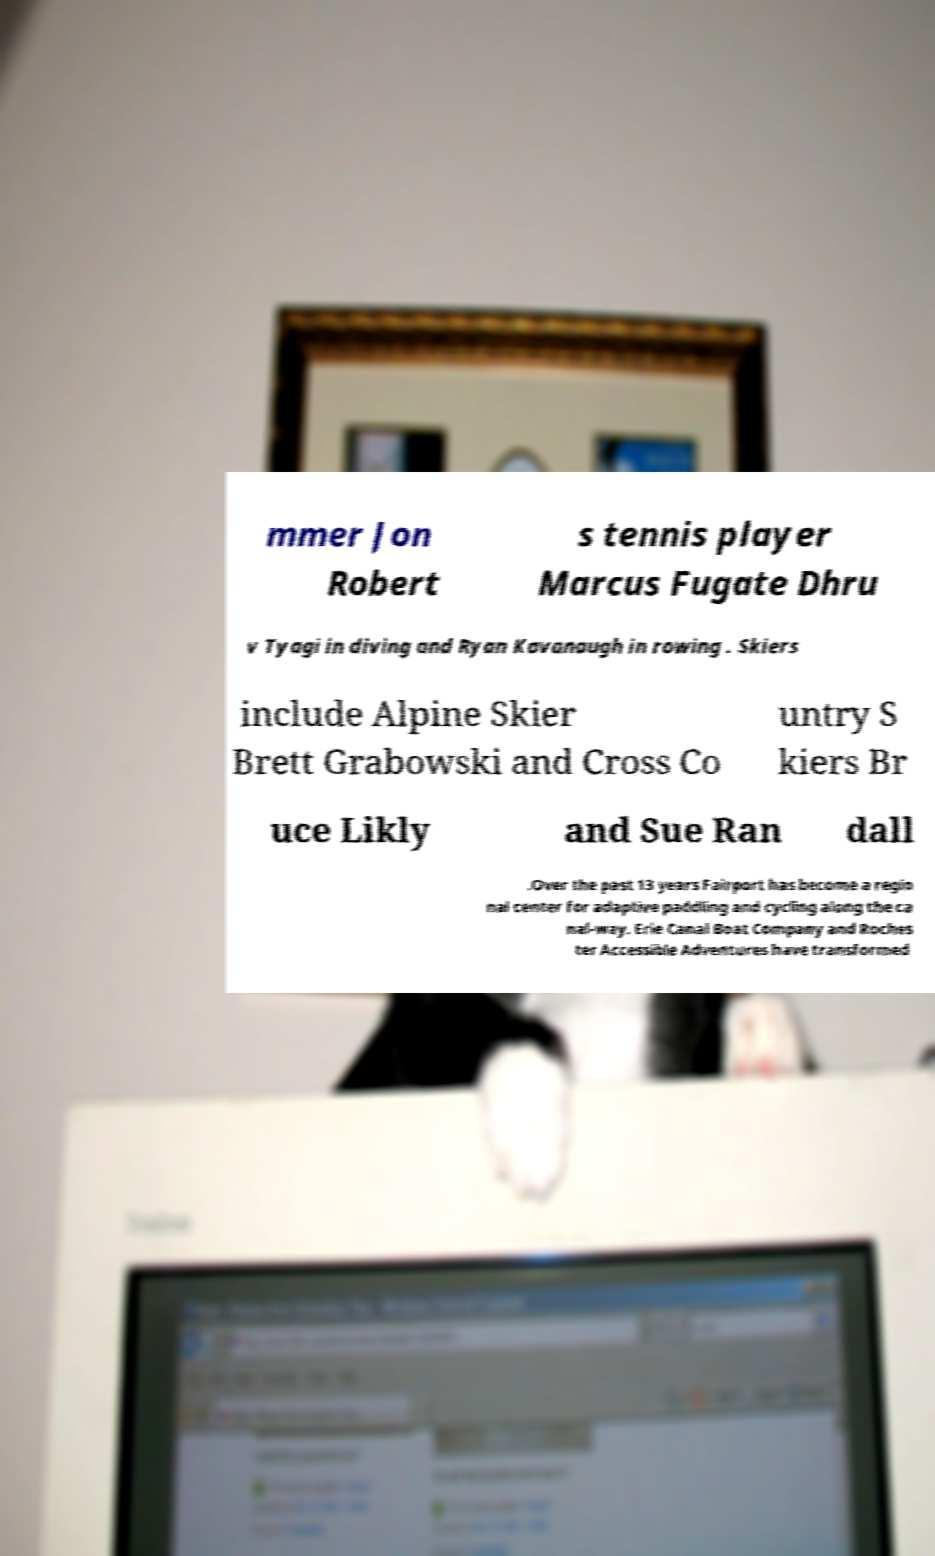Please read and relay the text visible in this image. What does it say? mmer Jon Robert s tennis player Marcus Fugate Dhru v Tyagi in diving and Ryan Kavanaugh in rowing . Skiers include Alpine Skier Brett Grabowski and Cross Co untry S kiers Br uce Likly and Sue Ran dall .Over the past 13 years Fairport has become a regio nal center for adaptive paddling and cycling along the ca nal-way. Erie Canal Boat Company and Roches ter Accessible Adventures have transformed 